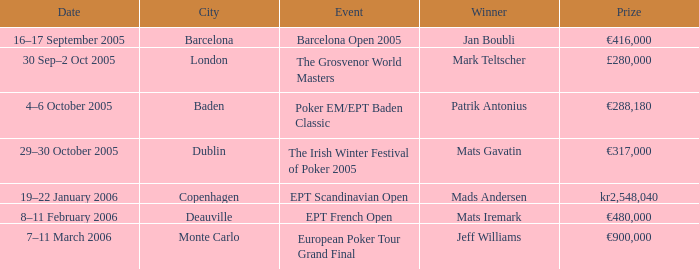Which incident resulted in mark teltscher's victory? The Grosvenor World Masters. 